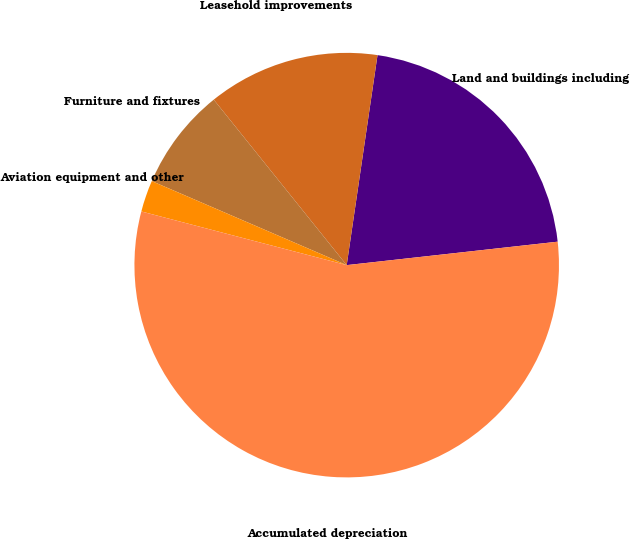<chart> <loc_0><loc_0><loc_500><loc_500><pie_chart><fcel>Land and buildings including<fcel>Leasehold improvements<fcel>Furniture and fixtures<fcel>Aviation equipment and other<fcel>Accumulated depreciation<nl><fcel>20.92%<fcel>13.09%<fcel>7.75%<fcel>2.41%<fcel>55.83%<nl></chart> 